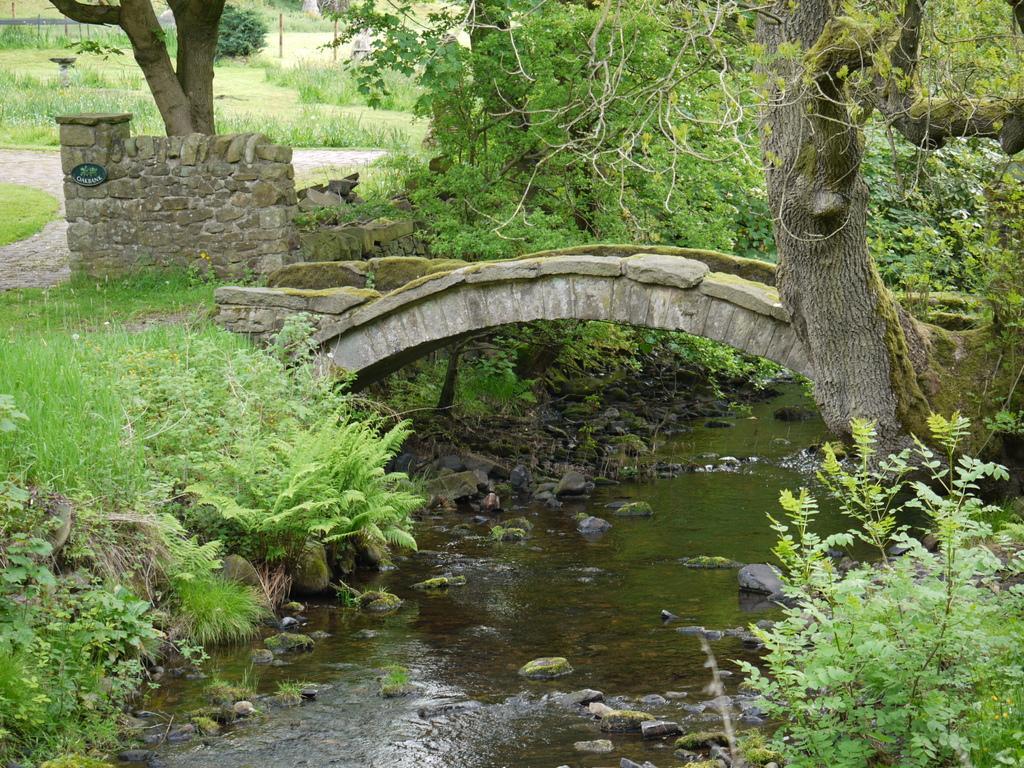Could you give a brief overview of what you see in this image? In this image on the left and right side, I can see the grass. In the middle I can see the bridge and the water. In the background, I can see the trees. 